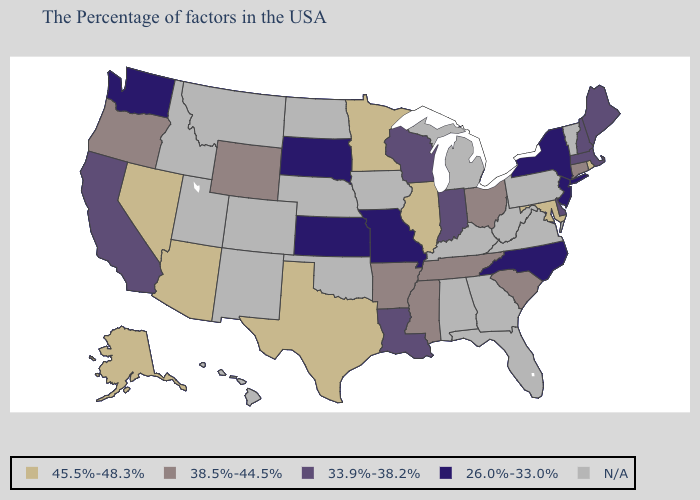What is the highest value in the MidWest ?
Quick response, please. 45.5%-48.3%. What is the highest value in the South ?
Quick response, please. 45.5%-48.3%. Does New Jersey have the lowest value in the USA?
Give a very brief answer. Yes. Name the states that have a value in the range N/A?
Quick response, please. Vermont, Pennsylvania, Virginia, West Virginia, Florida, Georgia, Michigan, Kentucky, Alabama, Iowa, Nebraska, Oklahoma, North Dakota, Colorado, New Mexico, Utah, Montana, Idaho, Hawaii. What is the value of Idaho?
Keep it brief. N/A. What is the value of Florida?
Short answer required. N/A. Among the states that border Connecticut , does Massachusetts have the highest value?
Answer briefly. No. What is the highest value in the USA?
Give a very brief answer. 45.5%-48.3%. Which states have the lowest value in the West?
Answer briefly. Washington. Is the legend a continuous bar?
Write a very short answer. No. What is the value of Alaska?
Keep it brief. 45.5%-48.3%. Does South Dakota have the lowest value in the MidWest?
Concise answer only. Yes. Name the states that have a value in the range N/A?
Short answer required. Vermont, Pennsylvania, Virginia, West Virginia, Florida, Georgia, Michigan, Kentucky, Alabama, Iowa, Nebraska, Oklahoma, North Dakota, Colorado, New Mexico, Utah, Montana, Idaho, Hawaii. What is the lowest value in the Northeast?
Short answer required. 26.0%-33.0%. 